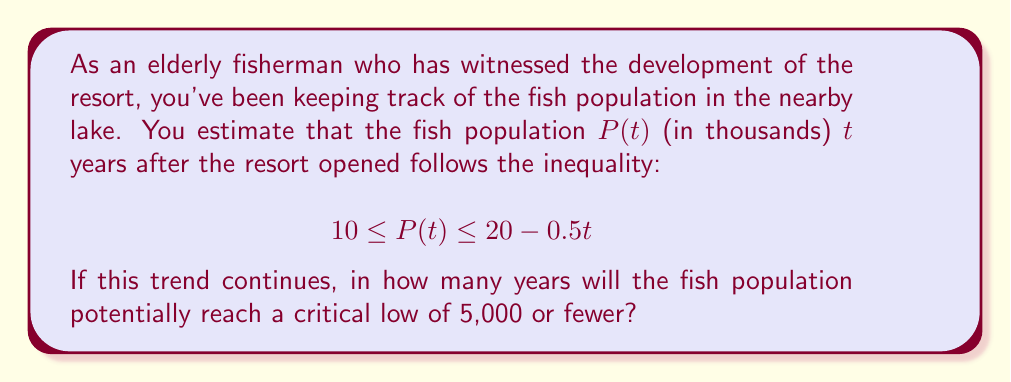Show me your answer to this math problem. To solve this problem, we need to find the value of $t$ when the upper bound of the inequality reaches 5,000 fish (or 5 in thousands).

1) The upper bound of the population is given by:
   $$ P(t) \leq 20 - 0.5t $$

2) We want to find when this upper bound equals 5:
   $$ 5 = 20 - 0.5t $$

3) Subtract 20 from both sides:
   $$ -15 = -0.5t $$

4) Divide both sides by -0.5:
   $$ 30 = t $$

5) Therefore, after 30 years, the upper bound of the fish population will be 5,000.

6) To verify, let's check the inequality at $t = 30$:
   $$ 10 \leq P(30) \leq 20 - 0.5(30) = 20 - 15 = 5 $$

This means that at 30 years, the population could be as low as 5,000 fish, which meets our critical threshold.

Note: The actual population might reach this critical level earlier, as 5,000 is only the upper bound at 30 years. However, given the information provided, we can only be certain that it will potentially reach this level at 30 years.
Answer: The fish population will potentially reach a critical low of 5,000 or fewer in 30 years. 